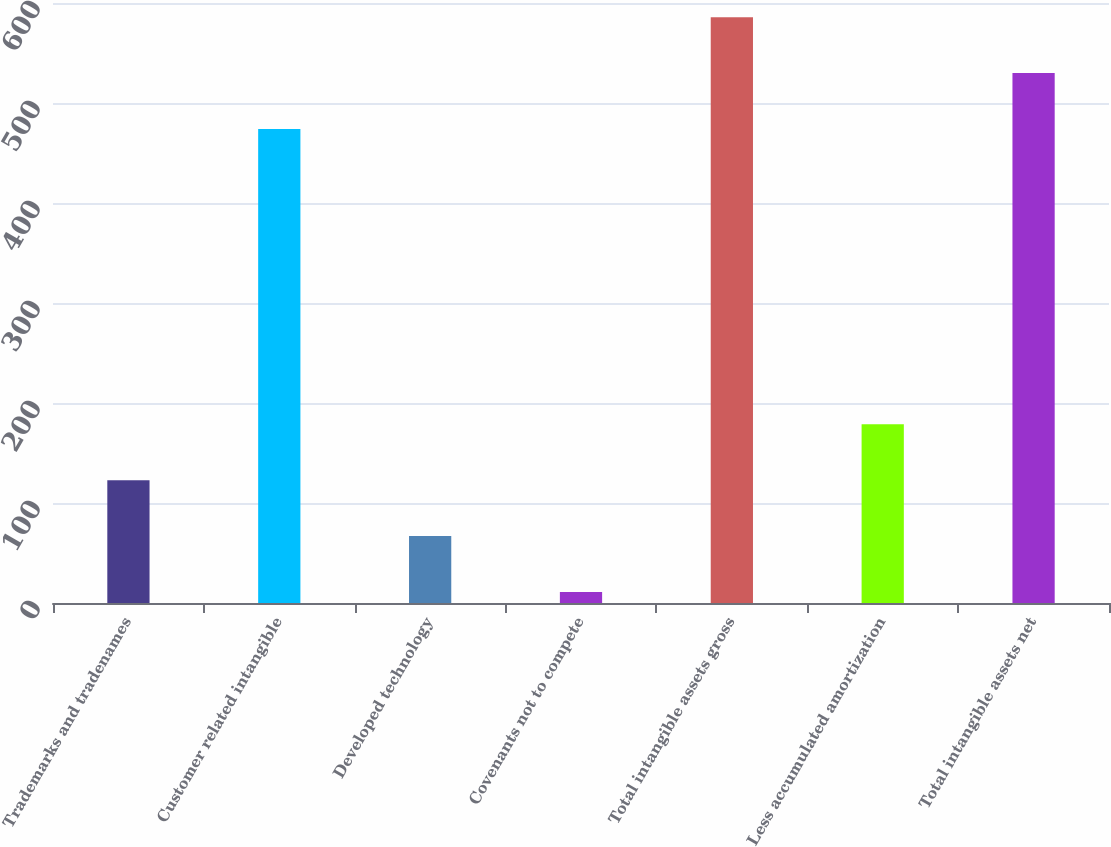<chart> <loc_0><loc_0><loc_500><loc_500><bar_chart><fcel>Trademarks and tradenames<fcel>Customer related intangible<fcel>Developed technology<fcel>Covenants not to compete<fcel>Total intangible assets gross<fcel>Less accumulated amortization<fcel>Total intangible assets net<nl><fcel>122.8<fcel>474<fcel>66.9<fcel>11<fcel>585.8<fcel>178.7<fcel>529.9<nl></chart> 